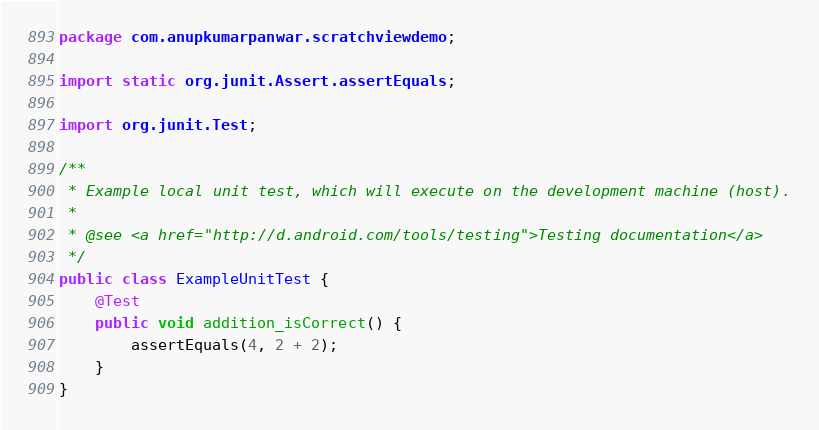<code> <loc_0><loc_0><loc_500><loc_500><_Java_>package com.anupkumarpanwar.scratchviewdemo;

import static org.junit.Assert.assertEquals;

import org.junit.Test;

/**
 * Example local unit test, which will execute on the development machine (host).
 *
 * @see <a href="http://d.android.com/tools/testing">Testing documentation</a>
 */
public class ExampleUnitTest {
    @Test
    public void addition_isCorrect() {
        assertEquals(4, 2 + 2);
    }
}</code> 